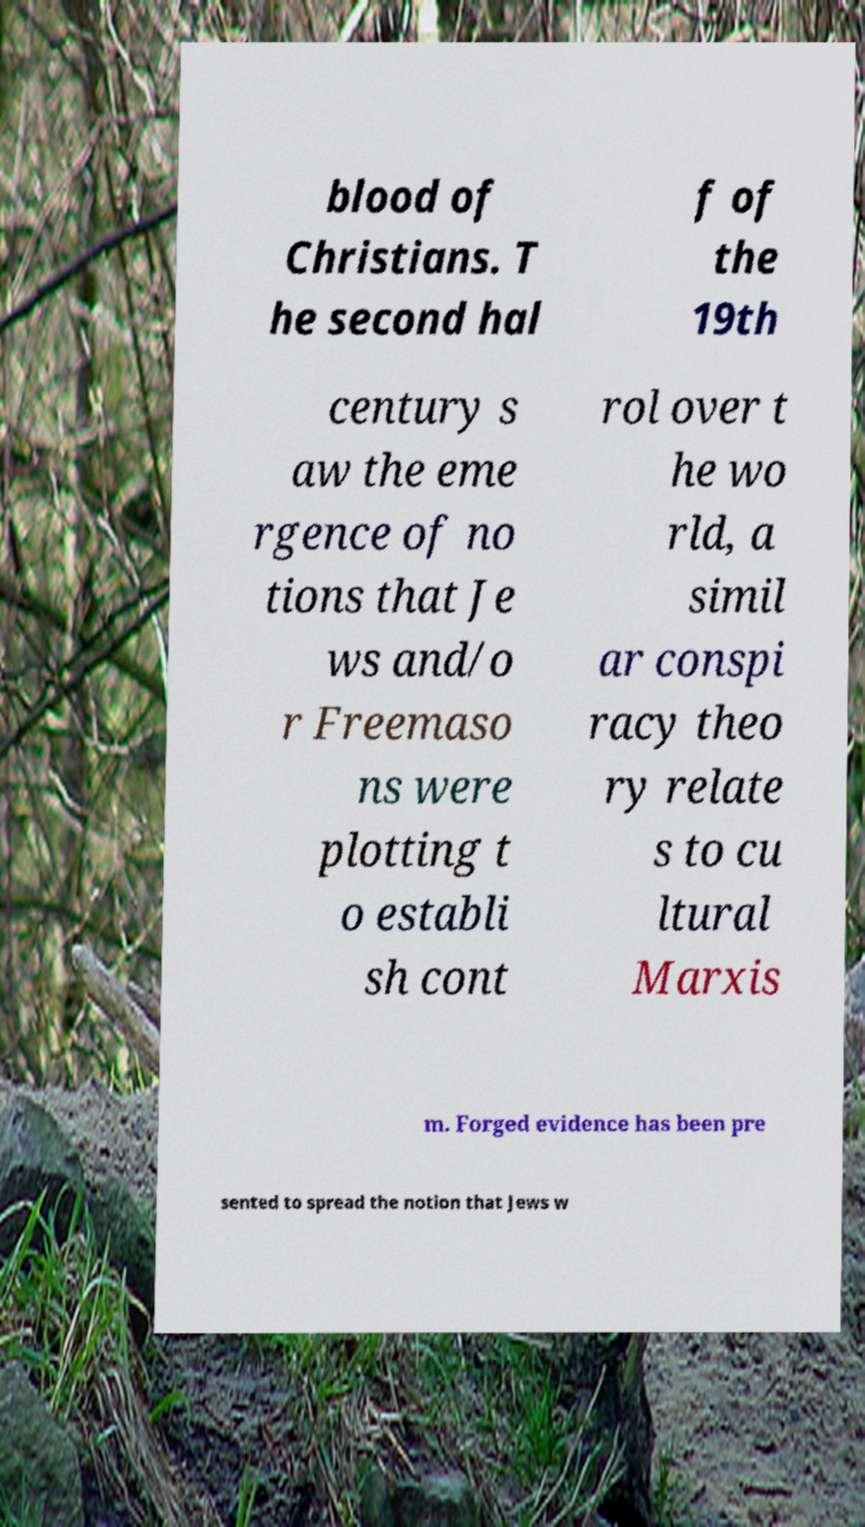Please read and relay the text visible in this image. What does it say? blood of Christians. T he second hal f of the 19th century s aw the eme rgence of no tions that Je ws and/o r Freemaso ns were plotting t o establi sh cont rol over t he wo rld, a simil ar conspi racy theo ry relate s to cu ltural Marxis m. Forged evidence has been pre sented to spread the notion that Jews w 